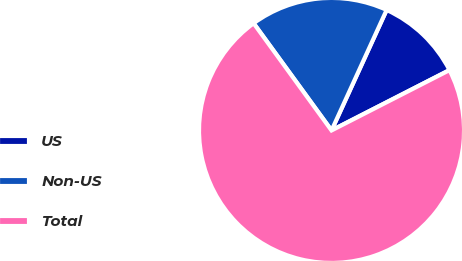Convert chart. <chart><loc_0><loc_0><loc_500><loc_500><pie_chart><fcel>US<fcel>Non-US<fcel>Total<nl><fcel>10.65%<fcel>16.83%<fcel>72.52%<nl></chart> 